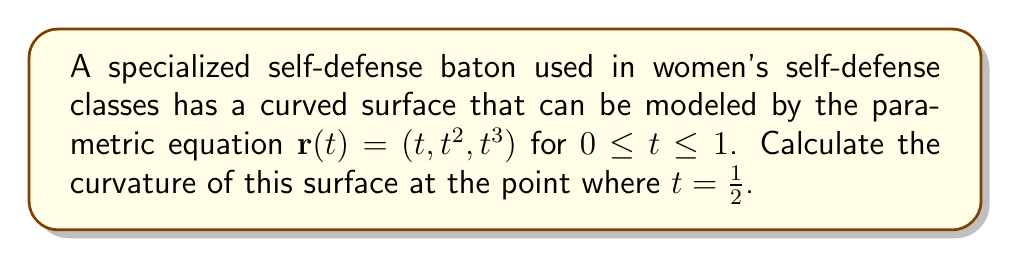Show me your answer to this math problem. To calculate the curvature of the parametric curve, we'll use the formula:

$$\kappa = \frac{|\mathbf{r}'(t) \times \mathbf{r}''(t)|}{|\mathbf{r}'(t)|^3}$$

Step 1: Calculate $\mathbf{r}'(t)$
$$\mathbf{r}'(t) = (1, 2t, 3t^2)$$

Step 2: Calculate $\mathbf{r}''(t)$
$$\mathbf{r}''(t) = (0, 2, 6t)$$

Step 3: Calculate $\mathbf{r}'(t) \times \mathbf{r}''(t)$
$$\mathbf{r}'(t) \times \mathbf{r}''(t) = \begin{vmatrix}
\mathbf{i} & \mathbf{j} & \mathbf{k} \\
1 & 2t & 3t^2 \\
0 & 2 & 6t
\end{vmatrix} = (6t^2 - 6t^2)\mathbf{i} + (6t - 0)\mathbf{j} + (2 - 4t)\mathbf{k} = 6t\mathbf{j} + (2 - 4t)\mathbf{k}$$

Step 4: Calculate $|\mathbf{r}'(t) \times \mathbf{r}''(t)|$
$$|\mathbf{r}'(t) \times \mathbf{r}''(t)| = \sqrt{(6t)^2 + (2 - 4t)^2} = \sqrt{36t^2 + 4 - 16t + 16t^2} = \sqrt{52t^2 - 16t + 4}$$

Step 5: Calculate $|\mathbf{r}'(t)|$
$$|\mathbf{r}'(t)| = \sqrt{1^2 + (2t)^2 + (3t^2)^2} = \sqrt{1 + 4t^2 + 9t^4}$$

Step 6: Substitute $t = \frac{1}{2}$ into the curvature formula
$$\kappa = \frac{\sqrt{52(\frac{1}{2})^2 - 16(\frac{1}{2}) + 4}}{(\sqrt{1 + 4(\frac{1}{2})^2 + 9(\frac{1}{2})^4})^3} = \frac{\sqrt{13 - 8 + 4}}{(\sqrt{1 + 1 + \frac{9}{16}})^3} = \frac{\sqrt{9}}{(\sqrt{\frac{41}{16}})^3} = \frac{3}{(\frac{\sqrt{41}}{4})^3}$$

Step 7: Simplify the final expression
$$\kappa = \frac{3 \cdot 64}{41\sqrt{41}} = \frac{192}{41\sqrt{41}}$$
Answer: $\frac{192}{41\sqrt{41}}$ 